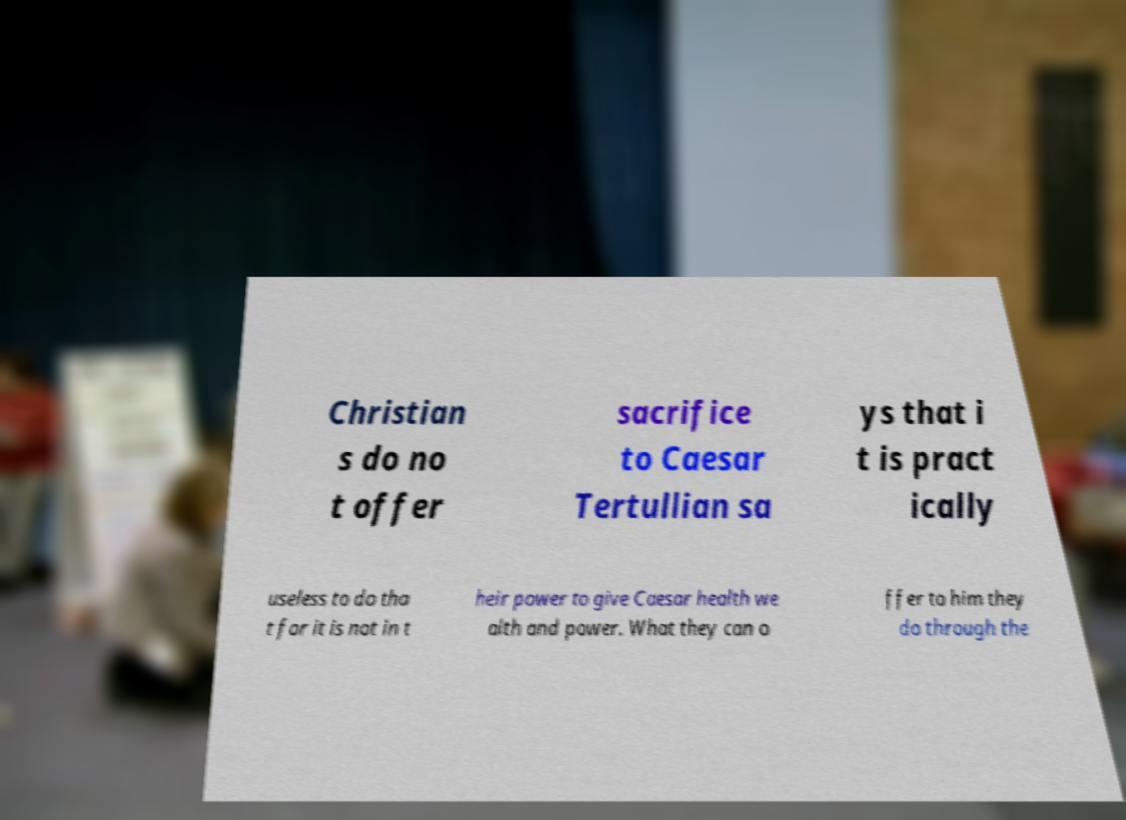Could you assist in decoding the text presented in this image and type it out clearly? Christian s do no t offer sacrifice to Caesar Tertullian sa ys that i t is pract ically useless to do tha t for it is not in t heir power to give Caesar health we alth and power. What they can o ffer to him they do through the 